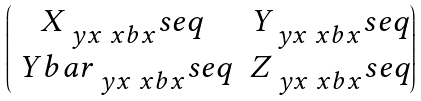Convert formula to latex. <formula><loc_0><loc_0><loc_500><loc_500>\begin{pmatrix} X _ { \ y x \ x b x } ^ { \ } s e q & Y _ { \ y x \ x b x } ^ { \ } s e q \\ \ Y b a r _ { \ y x \ x b x } ^ { \ } s e q & Z _ { \ y x \ x b x } ^ { \ } s e q \end{pmatrix}</formula> 